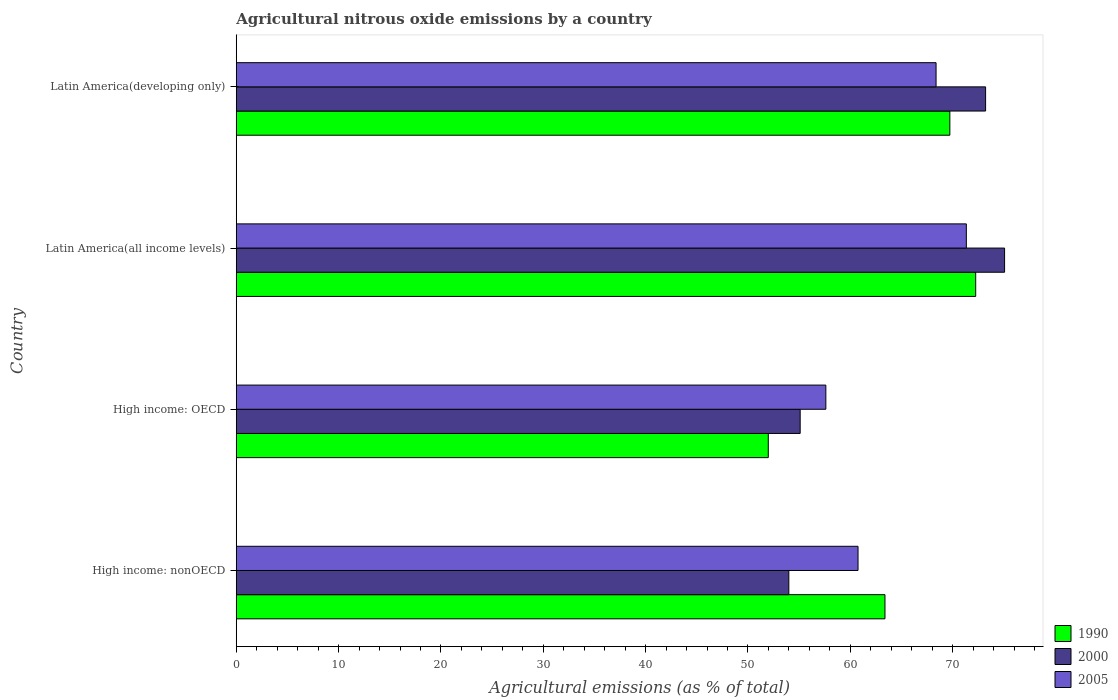How many different coloured bars are there?
Offer a very short reply. 3. How many groups of bars are there?
Keep it short and to the point. 4. Are the number of bars on each tick of the Y-axis equal?
Your answer should be compact. Yes. What is the label of the 4th group of bars from the top?
Offer a terse response. High income: nonOECD. What is the amount of agricultural nitrous oxide emitted in 2000 in High income: OECD?
Offer a terse response. 55.1. Across all countries, what is the maximum amount of agricultural nitrous oxide emitted in 2005?
Offer a terse response. 71.34. Across all countries, what is the minimum amount of agricultural nitrous oxide emitted in 2005?
Keep it short and to the point. 57.61. In which country was the amount of agricultural nitrous oxide emitted in 1990 maximum?
Provide a succinct answer. Latin America(all income levels). In which country was the amount of agricultural nitrous oxide emitted in 2005 minimum?
Ensure brevity in your answer.  High income: OECD. What is the total amount of agricultural nitrous oxide emitted in 2005 in the graph?
Ensure brevity in your answer.  258.09. What is the difference between the amount of agricultural nitrous oxide emitted in 2005 in High income: nonOECD and that in Latin America(developing only)?
Ensure brevity in your answer.  -7.62. What is the difference between the amount of agricultural nitrous oxide emitted in 1990 in High income: OECD and the amount of agricultural nitrous oxide emitted in 2005 in Latin America(all income levels)?
Make the answer very short. -19.35. What is the average amount of agricultural nitrous oxide emitted in 1990 per country?
Provide a short and direct response. 64.34. What is the difference between the amount of agricultural nitrous oxide emitted in 1990 and amount of agricultural nitrous oxide emitted in 2005 in Latin America(developing only)?
Ensure brevity in your answer.  1.35. In how many countries, is the amount of agricultural nitrous oxide emitted in 1990 greater than 66 %?
Your response must be concise. 2. What is the ratio of the amount of agricultural nitrous oxide emitted in 2005 in High income: OECD to that in Latin America(developing only)?
Your answer should be very brief. 0.84. What is the difference between the highest and the second highest amount of agricultural nitrous oxide emitted in 2005?
Give a very brief answer. 2.96. What is the difference between the highest and the lowest amount of agricultural nitrous oxide emitted in 1990?
Give a very brief answer. 20.27. Is the sum of the amount of agricultural nitrous oxide emitted in 2005 in Latin America(all income levels) and Latin America(developing only) greater than the maximum amount of agricultural nitrous oxide emitted in 2000 across all countries?
Your answer should be very brief. Yes. Are all the bars in the graph horizontal?
Offer a very short reply. Yes. How many countries are there in the graph?
Offer a terse response. 4. Are the values on the major ticks of X-axis written in scientific E-notation?
Provide a succinct answer. No. Does the graph contain any zero values?
Your response must be concise. No. Where does the legend appear in the graph?
Make the answer very short. Bottom right. How many legend labels are there?
Give a very brief answer. 3. What is the title of the graph?
Your response must be concise. Agricultural nitrous oxide emissions by a country. What is the label or title of the X-axis?
Your answer should be compact. Agricultural emissions (as % of total). What is the label or title of the Y-axis?
Keep it short and to the point. Country. What is the Agricultural emissions (as % of total) in 1990 in High income: nonOECD?
Offer a terse response. 63.39. What is the Agricultural emissions (as % of total) in 2000 in High income: nonOECD?
Your answer should be very brief. 54. What is the Agricultural emissions (as % of total) in 2005 in High income: nonOECD?
Your answer should be compact. 60.76. What is the Agricultural emissions (as % of total) of 1990 in High income: OECD?
Your answer should be compact. 51.99. What is the Agricultural emissions (as % of total) in 2000 in High income: OECD?
Make the answer very short. 55.1. What is the Agricultural emissions (as % of total) of 2005 in High income: OECD?
Provide a short and direct response. 57.61. What is the Agricultural emissions (as % of total) of 1990 in Latin America(all income levels)?
Offer a terse response. 72.26. What is the Agricultural emissions (as % of total) in 2000 in Latin America(all income levels)?
Offer a very short reply. 75.08. What is the Agricultural emissions (as % of total) in 2005 in Latin America(all income levels)?
Provide a succinct answer. 71.34. What is the Agricultural emissions (as % of total) in 1990 in Latin America(developing only)?
Keep it short and to the point. 69.73. What is the Agricultural emissions (as % of total) in 2000 in Latin America(developing only)?
Your answer should be very brief. 73.22. What is the Agricultural emissions (as % of total) of 2005 in Latin America(developing only)?
Your answer should be very brief. 68.38. Across all countries, what is the maximum Agricultural emissions (as % of total) in 1990?
Your answer should be compact. 72.26. Across all countries, what is the maximum Agricultural emissions (as % of total) in 2000?
Give a very brief answer. 75.08. Across all countries, what is the maximum Agricultural emissions (as % of total) in 2005?
Ensure brevity in your answer.  71.34. Across all countries, what is the minimum Agricultural emissions (as % of total) of 1990?
Offer a terse response. 51.99. Across all countries, what is the minimum Agricultural emissions (as % of total) in 2000?
Your answer should be very brief. 54. Across all countries, what is the minimum Agricultural emissions (as % of total) in 2005?
Your answer should be compact. 57.61. What is the total Agricultural emissions (as % of total) in 1990 in the graph?
Keep it short and to the point. 257.36. What is the total Agricultural emissions (as % of total) of 2000 in the graph?
Your answer should be compact. 257.4. What is the total Agricultural emissions (as % of total) of 2005 in the graph?
Provide a short and direct response. 258.1. What is the difference between the Agricultural emissions (as % of total) of 1990 in High income: nonOECD and that in High income: OECD?
Provide a succinct answer. 11.4. What is the difference between the Agricultural emissions (as % of total) of 2000 in High income: nonOECD and that in High income: OECD?
Provide a succinct answer. -1.11. What is the difference between the Agricultural emissions (as % of total) of 2005 in High income: nonOECD and that in High income: OECD?
Give a very brief answer. 3.15. What is the difference between the Agricultural emissions (as % of total) of 1990 in High income: nonOECD and that in Latin America(all income levels)?
Your answer should be compact. -8.87. What is the difference between the Agricultural emissions (as % of total) of 2000 in High income: nonOECD and that in Latin America(all income levels)?
Offer a terse response. -21.08. What is the difference between the Agricultural emissions (as % of total) in 2005 in High income: nonOECD and that in Latin America(all income levels)?
Provide a succinct answer. -10.58. What is the difference between the Agricultural emissions (as % of total) in 1990 in High income: nonOECD and that in Latin America(developing only)?
Provide a short and direct response. -6.34. What is the difference between the Agricultural emissions (as % of total) in 2000 in High income: nonOECD and that in Latin America(developing only)?
Your response must be concise. -19.23. What is the difference between the Agricultural emissions (as % of total) of 2005 in High income: nonOECD and that in Latin America(developing only)?
Ensure brevity in your answer.  -7.62. What is the difference between the Agricultural emissions (as % of total) of 1990 in High income: OECD and that in Latin America(all income levels)?
Ensure brevity in your answer.  -20.27. What is the difference between the Agricultural emissions (as % of total) of 2000 in High income: OECD and that in Latin America(all income levels)?
Your answer should be very brief. -19.97. What is the difference between the Agricultural emissions (as % of total) in 2005 in High income: OECD and that in Latin America(all income levels)?
Your response must be concise. -13.73. What is the difference between the Agricultural emissions (as % of total) in 1990 in High income: OECD and that in Latin America(developing only)?
Provide a short and direct response. -17.74. What is the difference between the Agricultural emissions (as % of total) of 2000 in High income: OECD and that in Latin America(developing only)?
Make the answer very short. -18.12. What is the difference between the Agricultural emissions (as % of total) in 2005 in High income: OECD and that in Latin America(developing only)?
Make the answer very short. -10.77. What is the difference between the Agricultural emissions (as % of total) of 1990 in Latin America(all income levels) and that in Latin America(developing only)?
Ensure brevity in your answer.  2.53. What is the difference between the Agricultural emissions (as % of total) of 2000 in Latin America(all income levels) and that in Latin America(developing only)?
Your answer should be very brief. 1.86. What is the difference between the Agricultural emissions (as % of total) of 2005 in Latin America(all income levels) and that in Latin America(developing only)?
Provide a short and direct response. 2.96. What is the difference between the Agricultural emissions (as % of total) in 1990 in High income: nonOECD and the Agricultural emissions (as % of total) in 2000 in High income: OECD?
Make the answer very short. 8.29. What is the difference between the Agricultural emissions (as % of total) of 1990 in High income: nonOECD and the Agricultural emissions (as % of total) of 2005 in High income: OECD?
Make the answer very short. 5.78. What is the difference between the Agricultural emissions (as % of total) of 2000 in High income: nonOECD and the Agricultural emissions (as % of total) of 2005 in High income: OECD?
Make the answer very short. -3.62. What is the difference between the Agricultural emissions (as % of total) in 1990 in High income: nonOECD and the Agricultural emissions (as % of total) in 2000 in Latin America(all income levels)?
Make the answer very short. -11.69. What is the difference between the Agricultural emissions (as % of total) in 1990 in High income: nonOECD and the Agricultural emissions (as % of total) in 2005 in Latin America(all income levels)?
Your response must be concise. -7.95. What is the difference between the Agricultural emissions (as % of total) in 2000 in High income: nonOECD and the Agricultural emissions (as % of total) in 2005 in Latin America(all income levels)?
Provide a succinct answer. -17.35. What is the difference between the Agricultural emissions (as % of total) of 1990 in High income: nonOECD and the Agricultural emissions (as % of total) of 2000 in Latin America(developing only)?
Your response must be concise. -9.83. What is the difference between the Agricultural emissions (as % of total) of 1990 in High income: nonOECD and the Agricultural emissions (as % of total) of 2005 in Latin America(developing only)?
Provide a succinct answer. -4.99. What is the difference between the Agricultural emissions (as % of total) in 2000 in High income: nonOECD and the Agricultural emissions (as % of total) in 2005 in Latin America(developing only)?
Keep it short and to the point. -14.39. What is the difference between the Agricultural emissions (as % of total) of 1990 in High income: OECD and the Agricultural emissions (as % of total) of 2000 in Latin America(all income levels)?
Your answer should be very brief. -23.09. What is the difference between the Agricultural emissions (as % of total) of 1990 in High income: OECD and the Agricultural emissions (as % of total) of 2005 in Latin America(all income levels)?
Offer a very short reply. -19.35. What is the difference between the Agricultural emissions (as % of total) of 2000 in High income: OECD and the Agricultural emissions (as % of total) of 2005 in Latin America(all income levels)?
Make the answer very short. -16.24. What is the difference between the Agricultural emissions (as % of total) in 1990 in High income: OECD and the Agricultural emissions (as % of total) in 2000 in Latin America(developing only)?
Provide a succinct answer. -21.23. What is the difference between the Agricultural emissions (as % of total) of 1990 in High income: OECD and the Agricultural emissions (as % of total) of 2005 in Latin America(developing only)?
Your answer should be very brief. -16.39. What is the difference between the Agricultural emissions (as % of total) in 2000 in High income: OECD and the Agricultural emissions (as % of total) in 2005 in Latin America(developing only)?
Give a very brief answer. -13.28. What is the difference between the Agricultural emissions (as % of total) of 1990 in Latin America(all income levels) and the Agricultural emissions (as % of total) of 2000 in Latin America(developing only)?
Your answer should be compact. -0.97. What is the difference between the Agricultural emissions (as % of total) of 1990 in Latin America(all income levels) and the Agricultural emissions (as % of total) of 2005 in Latin America(developing only)?
Your answer should be compact. 3.87. What is the difference between the Agricultural emissions (as % of total) in 2000 in Latin America(all income levels) and the Agricultural emissions (as % of total) in 2005 in Latin America(developing only)?
Your answer should be compact. 6.69. What is the average Agricultural emissions (as % of total) of 1990 per country?
Your response must be concise. 64.34. What is the average Agricultural emissions (as % of total) of 2000 per country?
Your response must be concise. 64.35. What is the average Agricultural emissions (as % of total) of 2005 per country?
Give a very brief answer. 64.52. What is the difference between the Agricultural emissions (as % of total) of 1990 and Agricultural emissions (as % of total) of 2000 in High income: nonOECD?
Make the answer very short. 9.39. What is the difference between the Agricultural emissions (as % of total) of 1990 and Agricultural emissions (as % of total) of 2005 in High income: nonOECD?
Offer a very short reply. 2.63. What is the difference between the Agricultural emissions (as % of total) in 2000 and Agricultural emissions (as % of total) in 2005 in High income: nonOECD?
Keep it short and to the point. -6.76. What is the difference between the Agricultural emissions (as % of total) of 1990 and Agricultural emissions (as % of total) of 2000 in High income: OECD?
Ensure brevity in your answer.  -3.12. What is the difference between the Agricultural emissions (as % of total) of 1990 and Agricultural emissions (as % of total) of 2005 in High income: OECD?
Provide a succinct answer. -5.62. What is the difference between the Agricultural emissions (as % of total) of 2000 and Agricultural emissions (as % of total) of 2005 in High income: OECD?
Provide a short and direct response. -2.51. What is the difference between the Agricultural emissions (as % of total) in 1990 and Agricultural emissions (as % of total) in 2000 in Latin America(all income levels)?
Give a very brief answer. -2.82. What is the difference between the Agricultural emissions (as % of total) in 1990 and Agricultural emissions (as % of total) in 2005 in Latin America(all income levels)?
Your answer should be compact. 0.91. What is the difference between the Agricultural emissions (as % of total) of 2000 and Agricultural emissions (as % of total) of 2005 in Latin America(all income levels)?
Your answer should be very brief. 3.74. What is the difference between the Agricultural emissions (as % of total) of 1990 and Agricultural emissions (as % of total) of 2000 in Latin America(developing only)?
Offer a very short reply. -3.49. What is the difference between the Agricultural emissions (as % of total) of 1990 and Agricultural emissions (as % of total) of 2005 in Latin America(developing only)?
Provide a short and direct response. 1.35. What is the difference between the Agricultural emissions (as % of total) of 2000 and Agricultural emissions (as % of total) of 2005 in Latin America(developing only)?
Make the answer very short. 4.84. What is the ratio of the Agricultural emissions (as % of total) in 1990 in High income: nonOECD to that in High income: OECD?
Your response must be concise. 1.22. What is the ratio of the Agricultural emissions (as % of total) of 2000 in High income: nonOECD to that in High income: OECD?
Ensure brevity in your answer.  0.98. What is the ratio of the Agricultural emissions (as % of total) in 2005 in High income: nonOECD to that in High income: OECD?
Provide a succinct answer. 1.05. What is the ratio of the Agricultural emissions (as % of total) of 1990 in High income: nonOECD to that in Latin America(all income levels)?
Keep it short and to the point. 0.88. What is the ratio of the Agricultural emissions (as % of total) in 2000 in High income: nonOECD to that in Latin America(all income levels)?
Ensure brevity in your answer.  0.72. What is the ratio of the Agricultural emissions (as % of total) of 2005 in High income: nonOECD to that in Latin America(all income levels)?
Ensure brevity in your answer.  0.85. What is the ratio of the Agricultural emissions (as % of total) in 2000 in High income: nonOECD to that in Latin America(developing only)?
Offer a very short reply. 0.74. What is the ratio of the Agricultural emissions (as % of total) in 2005 in High income: nonOECD to that in Latin America(developing only)?
Offer a very short reply. 0.89. What is the ratio of the Agricultural emissions (as % of total) in 1990 in High income: OECD to that in Latin America(all income levels)?
Your answer should be compact. 0.72. What is the ratio of the Agricultural emissions (as % of total) in 2000 in High income: OECD to that in Latin America(all income levels)?
Offer a terse response. 0.73. What is the ratio of the Agricultural emissions (as % of total) in 2005 in High income: OECD to that in Latin America(all income levels)?
Make the answer very short. 0.81. What is the ratio of the Agricultural emissions (as % of total) in 1990 in High income: OECD to that in Latin America(developing only)?
Ensure brevity in your answer.  0.75. What is the ratio of the Agricultural emissions (as % of total) of 2000 in High income: OECD to that in Latin America(developing only)?
Give a very brief answer. 0.75. What is the ratio of the Agricultural emissions (as % of total) in 2005 in High income: OECD to that in Latin America(developing only)?
Your answer should be very brief. 0.84. What is the ratio of the Agricultural emissions (as % of total) in 1990 in Latin America(all income levels) to that in Latin America(developing only)?
Provide a succinct answer. 1.04. What is the ratio of the Agricultural emissions (as % of total) of 2000 in Latin America(all income levels) to that in Latin America(developing only)?
Offer a terse response. 1.03. What is the ratio of the Agricultural emissions (as % of total) in 2005 in Latin America(all income levels) to that in Latin America(developing only)?
Ensure brevity in your answer.  1.04. What is the difference between the highest and the second highest Agricultural emissions (as % of total) of 1990?
Provide a succinct answer. 2.53. What is the difference between the highest and the second highest Agricultural emissions (as % of total) of 2000?
Offer a very short reply. 1.86. What is the difference between the highest and the second highest Agricultural emissions (as % of total) of 2005?
Provide a short and direct response. 2.96. What is the difference between the highest and the lowest Agricultural emissions (as % of total) in 1990?
Provide a succinct answer. 20.27. What is the difference between the highest and the lowest Agricultural emissions (as % of total) of 2000?
Your answer should be compact. 21.08. What is the difference between the highest and the lowest Agricultural emissions (as % of total) of 2005?
Make the answer very short. 13.73. 